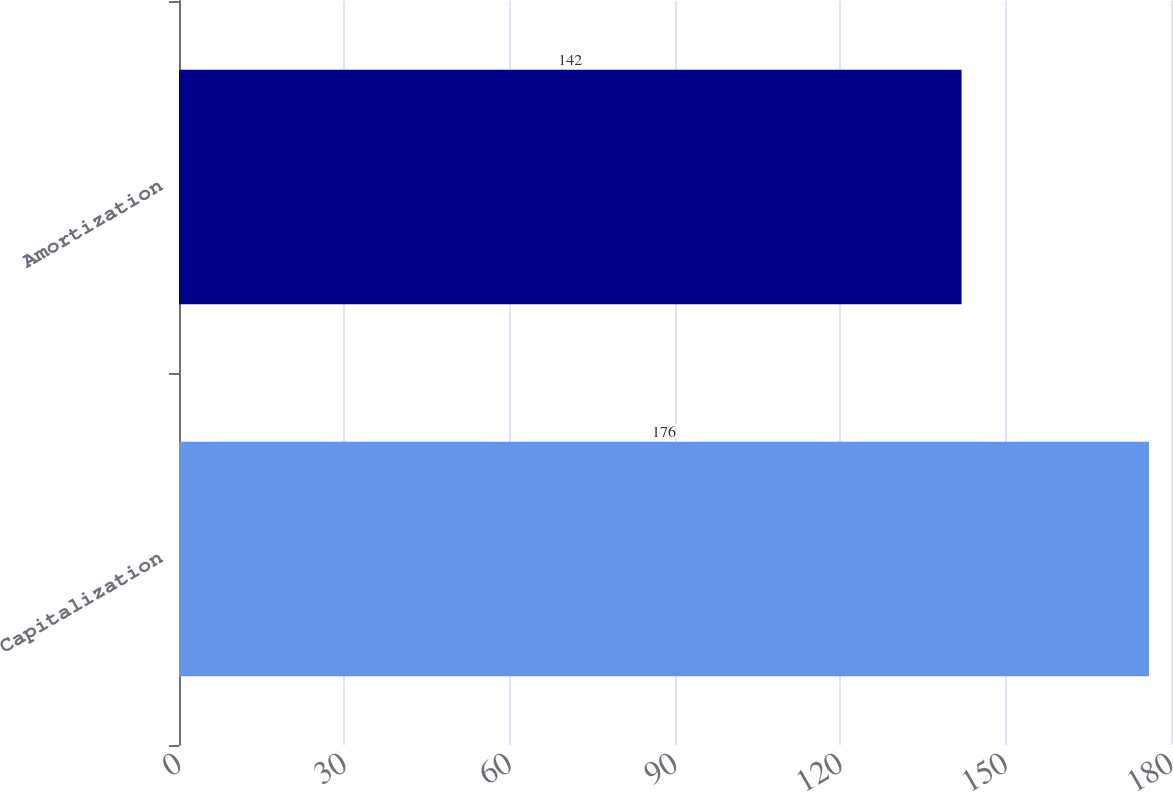Convert chart. <chart><loc_0><loc_0><loc_500><loc_500><bar_chart><fcel>Capitalization<fcel>Amortization<nl><fcel>176<fcel>142<nl></chart> 